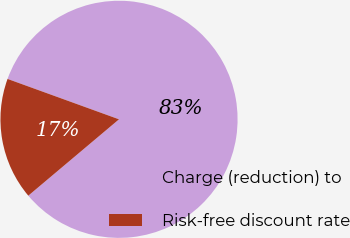Convert chart to OTSL. <chart><loc_0><loc_0><loc_500><loc_500><pie_chart><fcel>Charge (reduction) to<fcel>Risk-free discount rate<nl><fcel>83.33%<fcel>16.67%<nl></chart> 